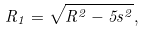Convert formula to latex. <formula><loc_0><loc_0><loc_500><loc_500>R _ { 1 } = \sqrt { R ^ { 2 } - 5 s ^ { 2 } } ,</formula> 